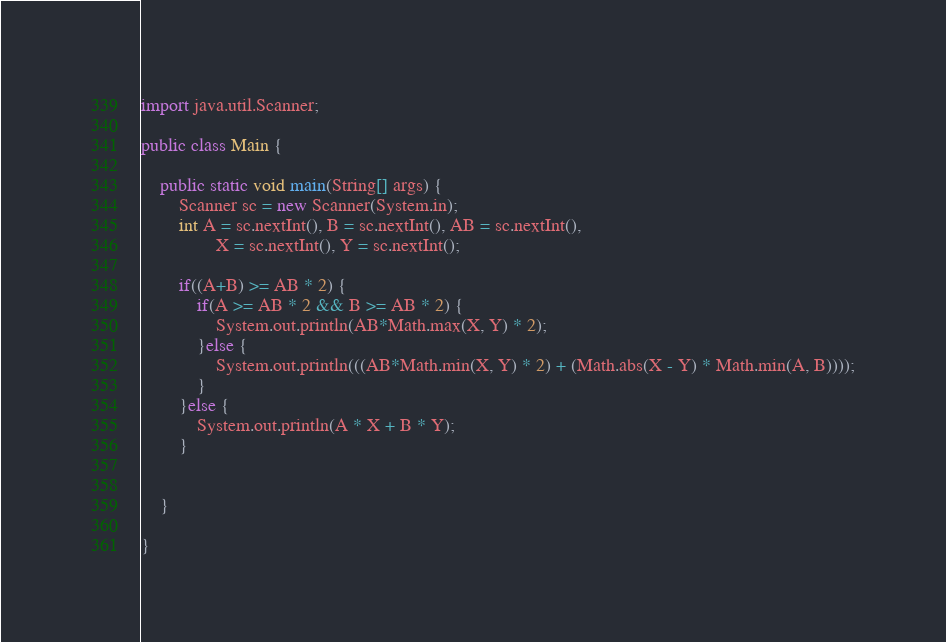Convert code to text. <code><loc_0><loc_0><loc_500><loc_500><_Java_>import java.util.Scanner;

public class Main {

	public static void main(String[] args) {
		Scanner sc = new Scanner(System.in);
		int A = sc.nextInt(), B = sc.nextInt(), AB = sc.nextInt(),
				X = sc.nextInt(), Y = sc.nextInt();
		
		if((A+B) >= AB * 2) {
			if(A >= AB * 2 && B >= AB * 2) {
				System.out.println(AB*Math.max(X, Y) * 2);
			}else {
				System.out.println(((AB*Math.min(X, Y) * 2) + (Math.abs(X - Y) * Math.min(A, B))));
			}
		}else {
			System.out.println(A * X + B * Y);
		}
		

	}

}</code> 